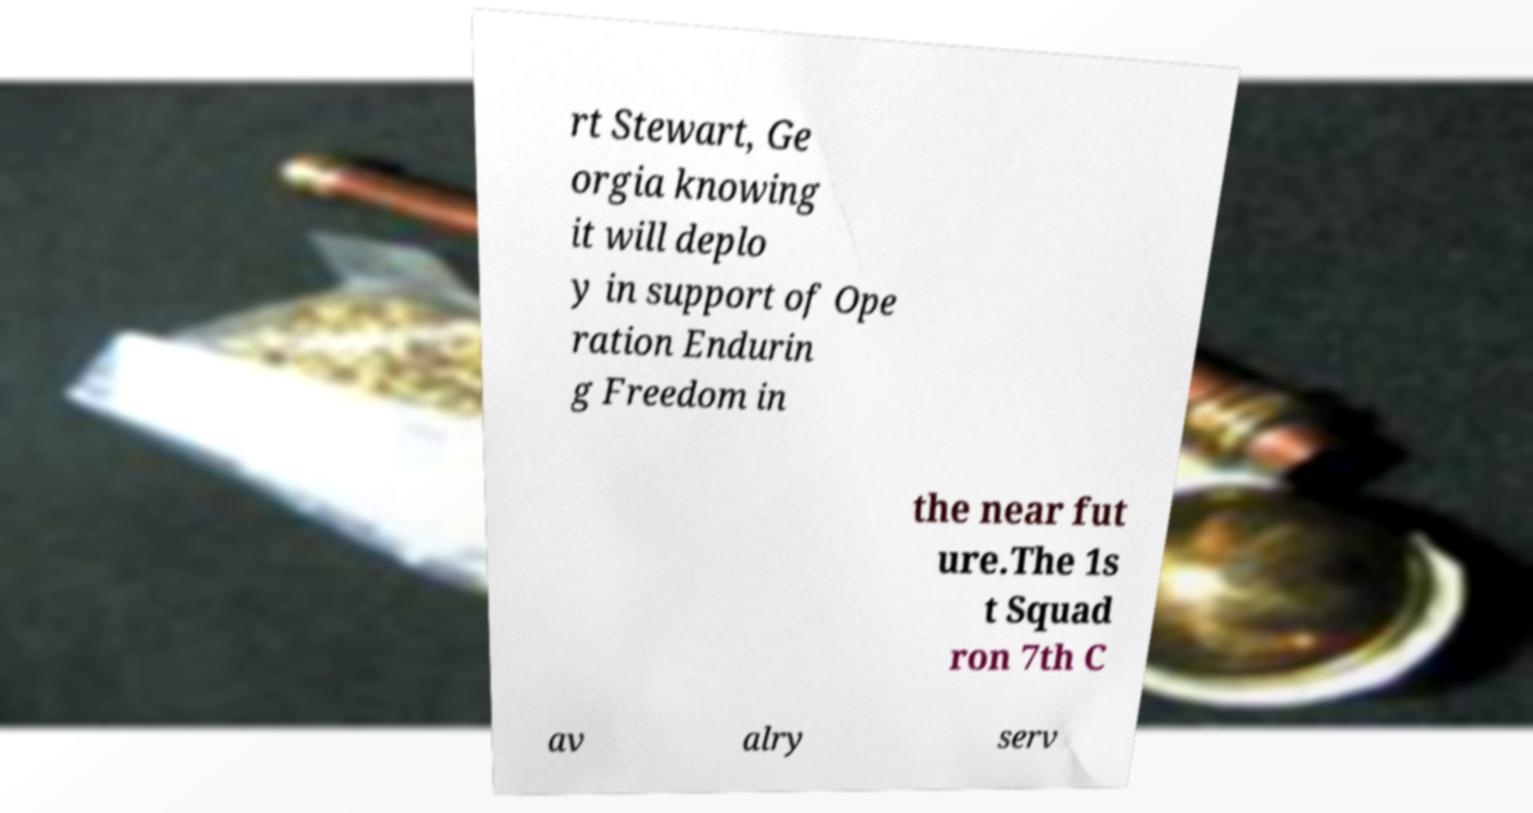Could you extract and type out the text from this image? rt Stewart, Ge orgia knowing it will deplo y in support of Ope ration Endurin g Freedom in the near fut ure.The 1s t Squad ron 7th C av alry serv 